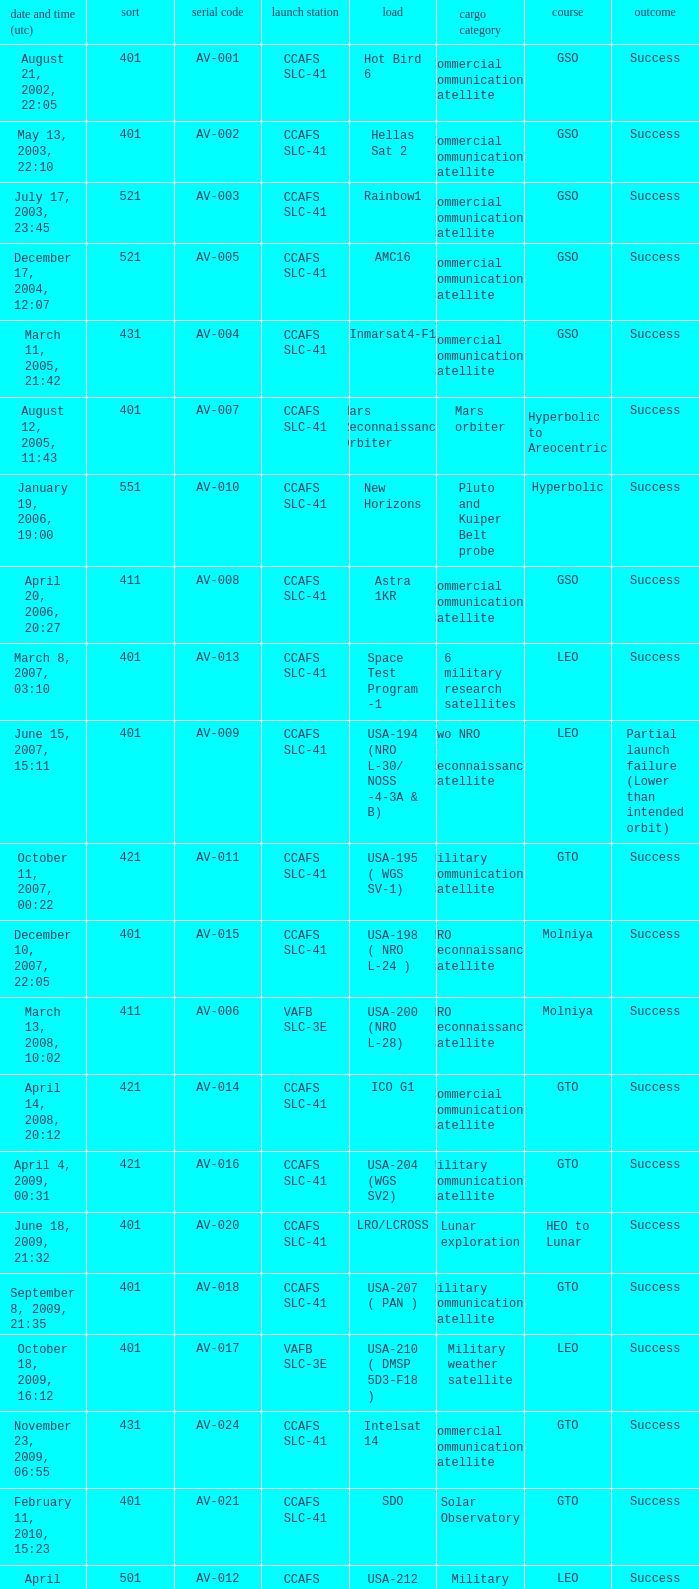When was the payload of Commercial Communications Satellite amc16? December 17, 2004, 12:07. 